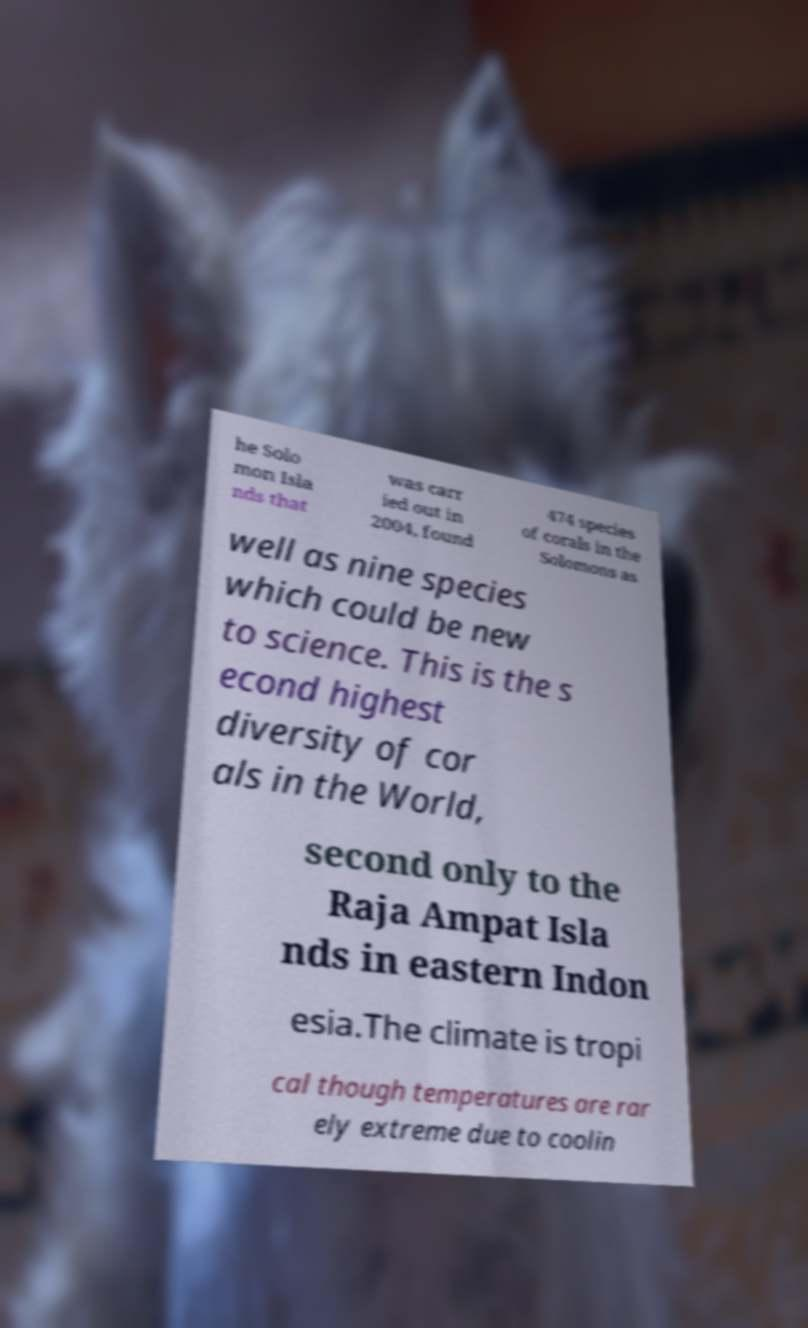Could you extract and type out the text from this image? he Solo mon Isla nds that was carr ied out in 2004, found 474 species of corals in the Solomons as well as nine species which could be new to science. This is the s econd highest diversity of cor als in the World, second only to the Raja Ampat Isla nds in eastern Indon esia.The climate is tropi cal though temperatures are rar ely extreme due to coolin 